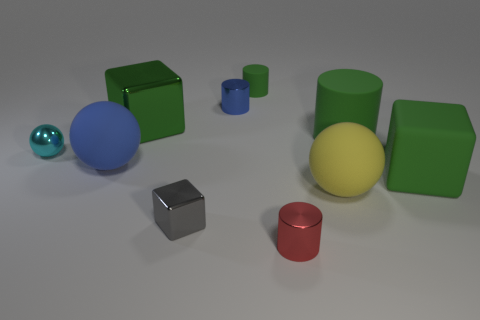There is a big green thing that is on the left side of the ball that is right of the cylinder that is in front of the big yellow rubber sphere; what is its shape?
Give a very brief answer. Cube. Do the big matte sphere behind the yellow object and the matte cylinder on the right side of the big yellow rubber ball have the same color?
Your response must be concise. No. Are there fewer big rubber things in front of the tiny green cylinder than gray shiny objects right of the big yellow object?
Your answer should be compact. No. Are there any other things that are the same shape as the green metal thing?
Your response must be concise. Yes. There is a matte thing that is the same shape as the large metal thing; what color is it?
Your answer should be very brief. Green. There is a red thing; is its shape the same as the metal object left of the big green shiny block?
Your answer should be very brief. No. How many objects are green objects that are behind the big green rubber cube or big metal cubes that are to the left of the blue cylinder?
Provide a short and direct response. 3. What material is the big green cylinder?
Your answer should be very brief. Rubber. What is the size of the blue thing right of the large blue thing?
Offer a very short reply. Small. What is the material of the small thing that is left of the big sphere on the left side of the shiny object behind the green metal block?
Give a very brief answer. Metal. 